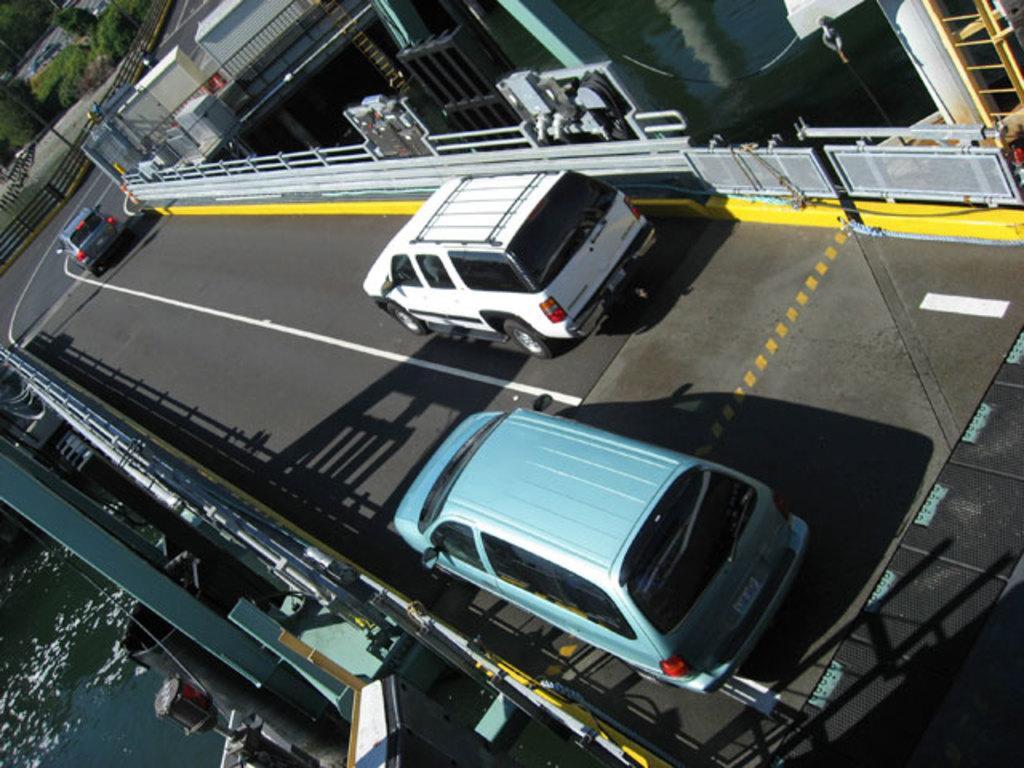Describe this image in one or two sentences. In the picture we can see a road with railings to its sides and on the road we can see some vehicles and behind the railing we can see water and in the background, we can see a railing and behind it we can see a pole and some trees. 